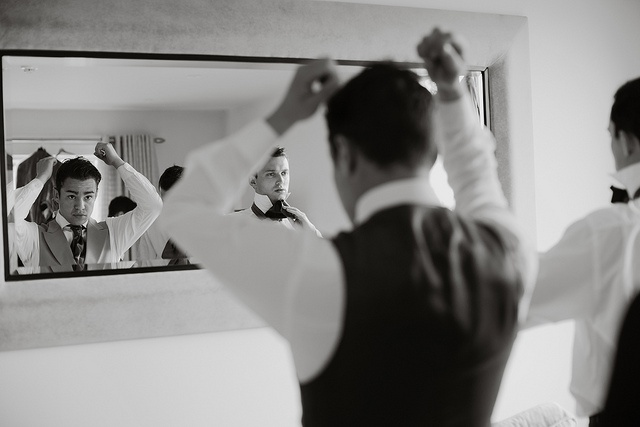Describe the objects in this image and their specific colors. I can see people in black, darkgray, gray, and lightgray tones, people in black, darkgray, gray, and lightgray tones, people in black, darkgray, gray, and lightgray tones, tie in black, gray, and darkgray tones, and tie in black and gray tones in this image. 